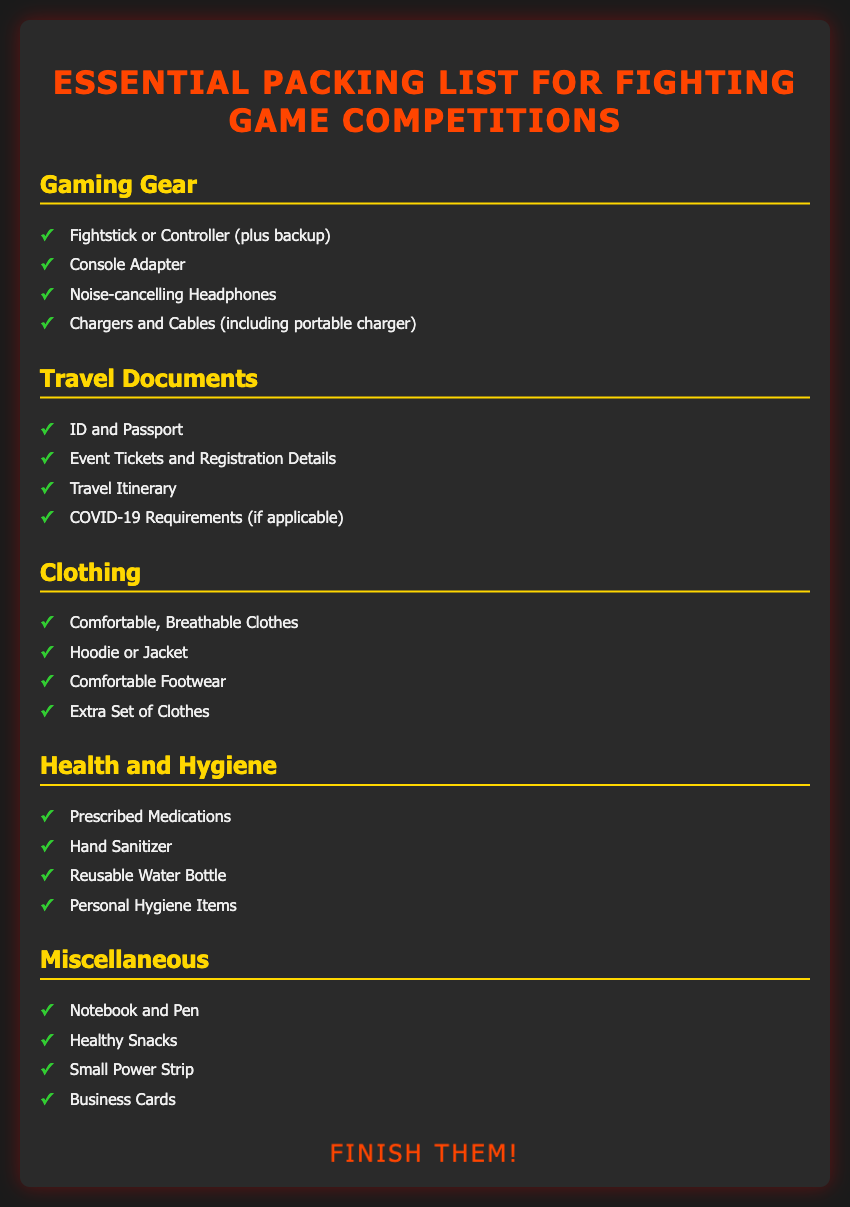What is the title of the document? The title is displayed prominently at the top of the document, indicating its purpose as a packing list for a specific event.
Answer: Essential Packing List for Fighting Game Competitions How many categories are in the packing list? The document lists various categories of items to pack, specifically organized for the event, allowing for quick reference.
Answer: Five What type of headphones are recommended? The document describes essential gaming gear, including items that enhance the gaming experience and provide comfort.
Answer: Noise-cancelling Headphones What item is used for hydration? The document emphasizes the importance of health and hygiene, with a focus on personal care and wellness during travel.
Answer: Reusable Water Bottle What should you bring in case of illness? The health and hygiene section highlights important items for personal care and preparedness for unexpected situations.
Answer: Prescribed Medications What clothing item is suggested for cooler weather? The clothing category indicates items that would provide comfort and warmth, accommodating different environmental conditions.
Answer: Hoodie or Jacket How many items are listed under Miscellaneous? The miscellaneous category includes items that support convenience and networking during the competition.
Answer: Four What is the last phrase in the document? The document concludes with a phrase meant to energize competitors and motivate them as they prepare for their matches.
Answer: Finish Them! 